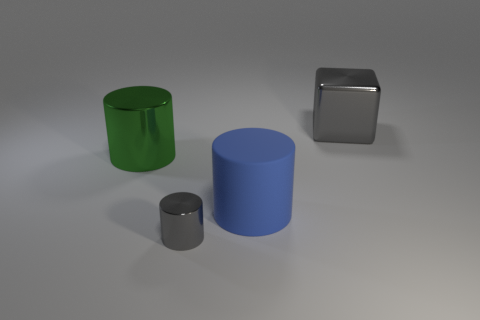Add 2 big metal balls. How many objects exist? 6 Subtract all cylinders. How many objects are left? 1 Subtract 1 gray cylinders. How many objects are left? 3 Subtract all big blue matte objects. Subtract all large yellow objects. How many objects are left? 3 Add 3 large green shiny things. How many large green shiny things are left? 4 Add 2 cyan cylinders. How many cyan cylinders exist? 2 